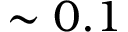Convert formula to latex. <formula><loc_0><loc_0><loc_500><loc_500>\sim 0 . 1</formula> 